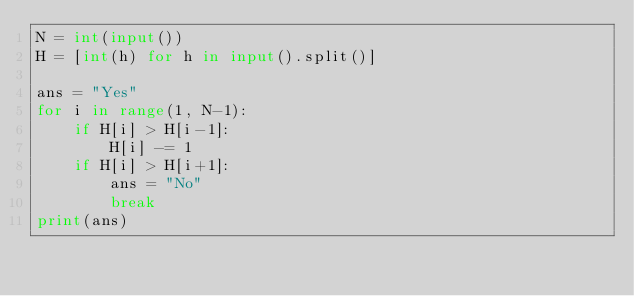<code> <loc_0><loc_0><loc_500><loc_500><_Python_>N = int(input())
H = [int(h) for h in input().split()]

ans = "Yes"
for i in range(1, N-1):
    if H[i] > H[i-1]:
        H[i] -= 1
    if H[i] > H[i+1]:
        ans = "No"
        break
print(ans)</code> 